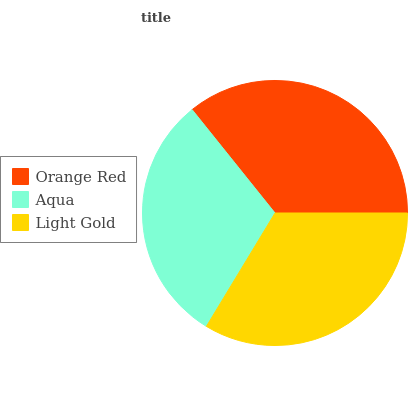Is Aqua the minimum?
Answer yes or no. Yes. Is Orange Red the maximum?
Answer yes or no. Yes. Is Light Gold the minimum?
Answer yes or no. No. Is Light Gold the maximum?
Answer yes or no. No. Is Light Gold greater than Aqua?
Answer yes or no. Yes. Is Aqua less than Light Gold?
Answer yes or no. Yes. Is Aqua greater than Light Gold?
Answer yes or no. No. Is Light Gold less than Aqua?
Answer yes or no. No. Is Light Gold the high median?
Answer yes or no. Yes. Is Light Gold the low median?
Answer yes or no. Yes. Is Aqua the high median?
Answer yes or no. No. Is Orange Red the low median?
Answer yes or no. No. 